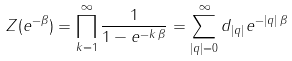<formula> <loc_0><loc_0><loc_500><loc_500>Z ( e ^ { - \beta } ) = \prod _ { k = 1 } ^ { \infty } \frac { 1 } { 1 - e ^ { - k \, \beta } } = \sum _ { | q | = 0 } ^ { \infty } d _ { | q | } e ^ { - | q | \, \beta }</formula> 